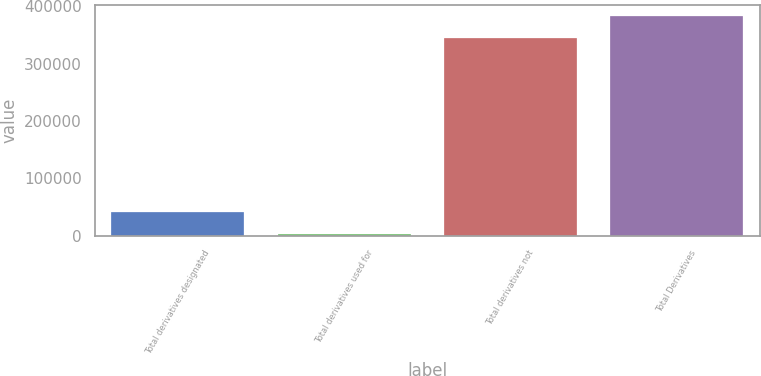Convert chart. <chart><loc_0><loc_0><loc_500><loc_500><bar_chart><fcel>Total derivatives designated<fcel>Total derivatives used for<fcel>Total derivatives not<fcel>Total Derivatives<nl><fcel>40552.9<fcel>2697<fcel>345059<fcel>382915<nl></chart> 